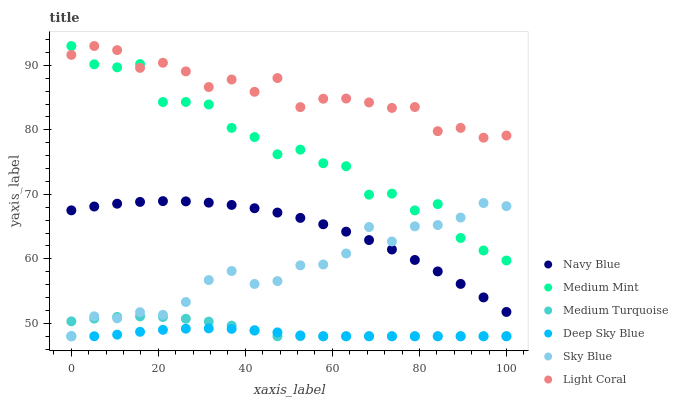Does Deep Sky Blue have the minimum area under the curve?
Answer yes or no. Yes. Does Light Coral have the maximum area under the curve?
Answer yes or no. Yes. Does Medium Turquoise have the minimum area under the curve?
Answer yes or no. No. Does Medium Turquoise have the maximum area under the curve?
Answer yes or no. No. Is Deep Sky Blue the smoothest?
Answer yes or no. Yes. Is Medium Mint the roughest?
Answer yes or no. Yes. Is Medium Turquoise the smoothest?
Answer yes or no. No. Is Medium Turquoise the roughest?
Answer yes or no. No. Does Medium Turquoise have the lowest value?
Answer yes or no. Yes. Does Navy Blue have the lowest value?
Answer yes or no. No. Does Light Coral have the highest value?
Answer yes or no. Yes. Does Medium Turquoise have the highest value?
Answer yes or no. No. Is Deep Sky Blue less than Navy Blue?
Answer yes or no. Yes. Is Light Coral greater than Navy Blue?
Answer yes or no. Yes. Does Light Coral intersect Medium Mint?
Answer yes or no. Yes. Is Light Coral less than Medium Mint?
Answer yes or no. No. Is Light Coral greater than Medium Mint?
Answer yes or no. No. Does Deep Sky Blue intersect Navy Blue?
Answer yes or no. No. 